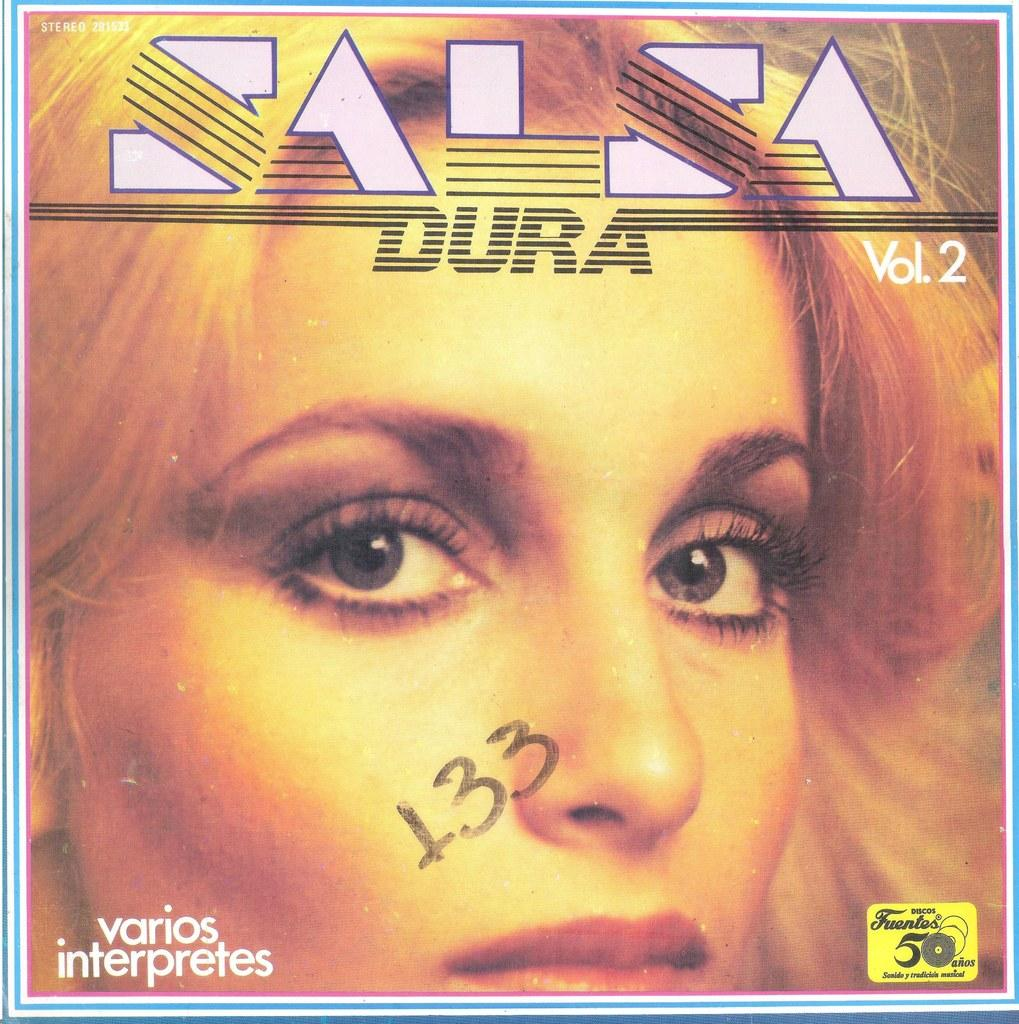Provide a one-sentence caption for the provided image. The cover of an album with the number 133 written on it. 